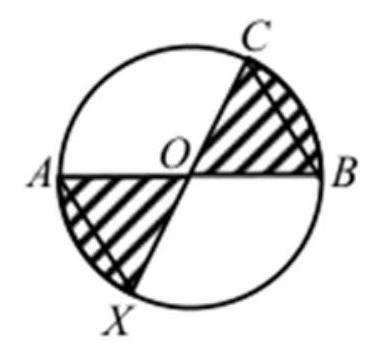What principles of geometry help in solving problems like the one depicted in this diagram? To solve such geometry problems, principles like theorems on circle chords, angle properties, symmetry, and properties of triangles are usually crucial. In this specific problem, understanding the properties of circle segments intersected by diameters and the properties of isosceles triangles are essential. 